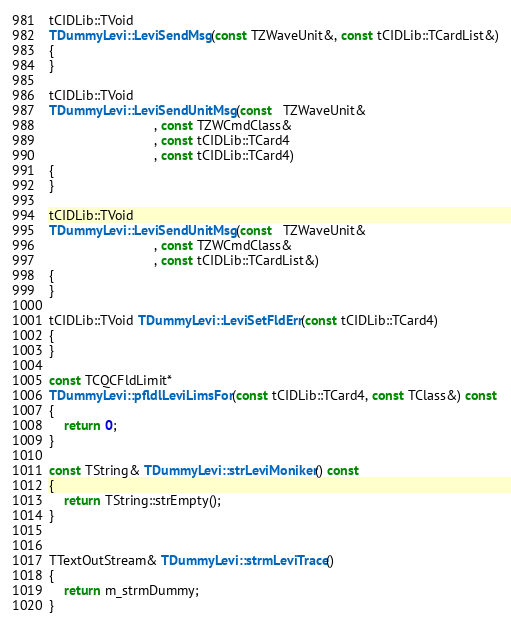Convert code to text. <code><loc_0><loc_0><loc_500><loc_500><_C++_>

tCIDLib::TVoid
TDummyLevi::LeviSendMsg(const TZWaveUnit&, const tCIDLib::TCardList&)
{
}

tCIDLib::TVoid
TDummyLevi::LeviSendUnitMsg(const   TZWaveUnit&
                            , const TZWCmdClass&
                            , const tCIDLib::TCard4
                            , const tCIDLib::TCard4)
{
}

tCIDLib::TVoid
TDummyLevi::LeviSendUnitMsg(const   TZWaveUnit&
                            , const TZWCmdClass&
                            , const tCIDLib::TCardList&)
{
}

tCIDLib::TVoid TDummyLevi::LeviSetFldErr(const tCIDLib::TCard4)
{
}

const TCQCFldLimit*
TDummyLevi::pfldlLeviLimsFor(const tCIDLib::TCard4, const TClass&) const
{
    return 0;
}

const TString& TDummyLevi::strLeviMoniker() const
{
    return TString::strEmpty();
}


TTextOutStream& TDummyLevi::strmLeviTrace()
{
    return m_strmDummy;
}


</code> 